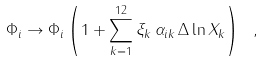Convert formula to latex. <formula><loc_0><loc_0><loc_500><loc_500>\Phi _ { i } \to \Phi _ { i } \left ( 1 + \sum _ { k = 1 } ^ { 1 2 } \xi _ { k } \, \alpha _ { i k } \, \Delta \ln X _ { k } \right ) \ ,</formula> 